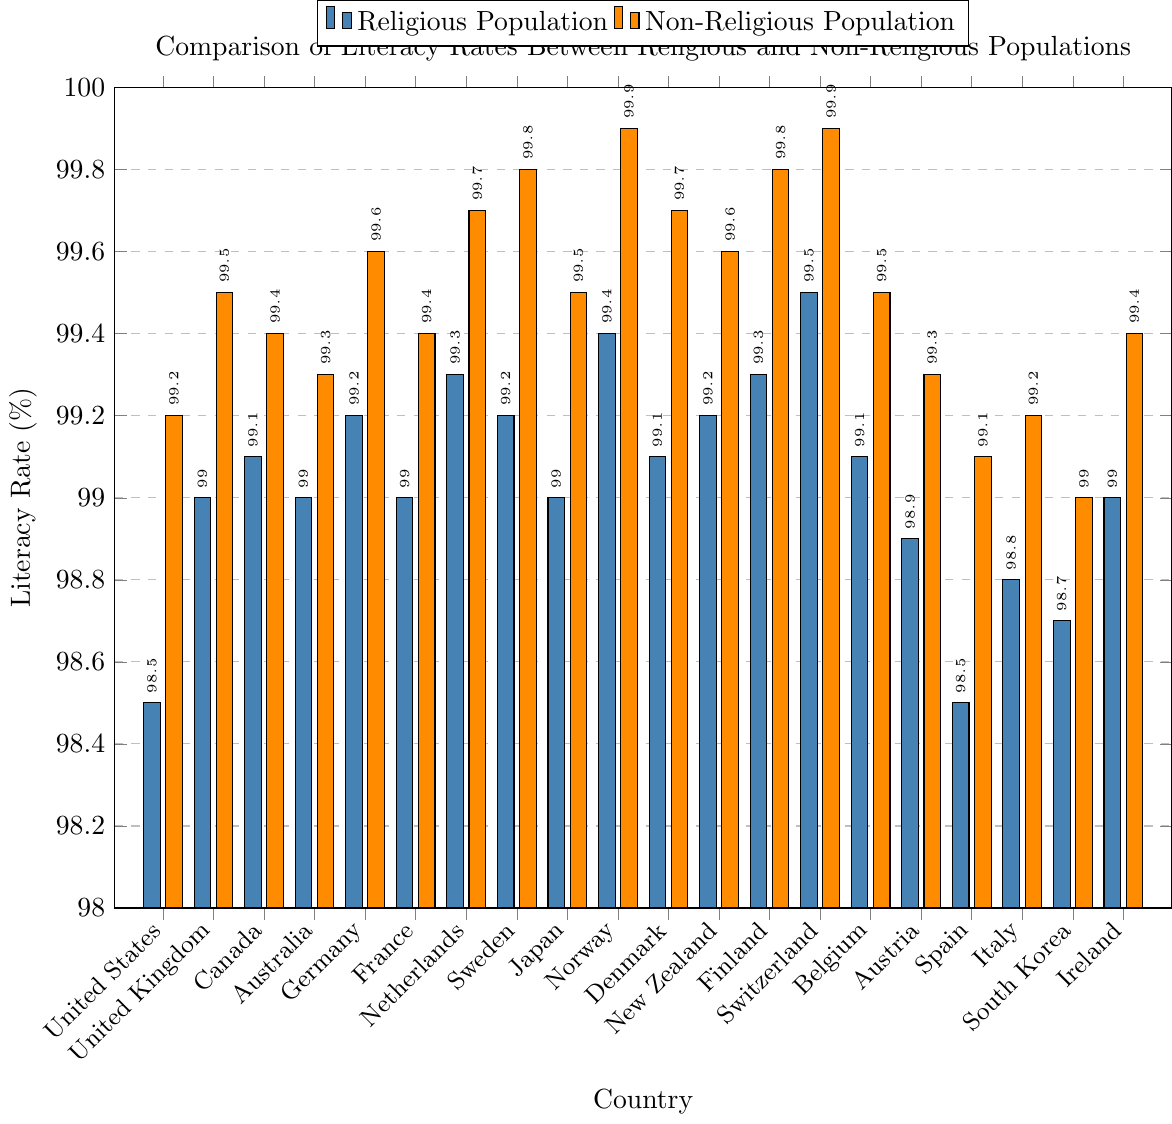Which country has the highest literacy rate among the non-religious population? Look for the tallest orange bar in the chart as it represents the non-religious population literacy rate, the tallest is Norway and Switzerland with literacy rates of 99.9%.
Answer: Norway and Switzerland What is the literacy rate difference between religious and non-religious populations in the United States? Identify the literacy rates for both populations in the United States, i.e., 98.5% (religious) and 99.2% (non-religious), then calculate the difference: 99.2% - 98.5% = 0.7%.
Answer: 0.7% Which country has the smallest difference in literacy rates between its religious and non-religious populations? For each country, compute the difference between religious and non-religious literacy rates. Denmark has a difference of only 0.6%, from 99.1% (religious) to 99.7% (non-religious).
Answer: Denmark In how many countries is the literacy rate of the non-religious population higher than that of the religious population by at least 0.5%? Calculate the literacy rate difference for each country, count the number of countries where the difference is 0.5% or more: United States (0.7%), United Kingdom (0.5%), Germany (0.4%), Netherlands (0.4%), Sweden (0.6%), Norway (0.5%), Denmark (0.6%), Finland (0.5%), Switzerland (0.4%). There are 8 such countries.
Answer: 8 What is the average literacy rate of the religious population in the listed countries? Sum the literacy rates of the religious populations (98.5 + 99.0 + 99.1 + 99.0 + 99.2 + 99.0 + 99.3 + 99.2 + 99.0 + 99.4 + 99.1 + 99.2 + 99.3 + 99.5 + 99.1 + 98.9 + 98.5 + 98.8 + 98.7 + 99.0) = 1976.9, then divide by the number of countries (20): 1976.9 / 20 = 98.845.
Answer: 98.845 Is the literacy rate higher in the religious or non-religious population in Italy? Check the bar heights for Italy, the religious population is at 98.8% and the non-religious is at 99.2%, so the non-religious literacy rate is higher.
Answer: Non-religious Which country shows the largest literacy rate for the religious population? Find the tallest blue bar, which represents the literacy rate for the religious population. Switzerland with 99.5% has the highest literacy rate.
Answer: Switzerland How many countries have a religious literacy rate below 99%? Count the number of blue bars representing the religious literacy rates below 99%: United States, Austria, Spain, Italy, and South Korea. There are 5 such countries.
Answer: 5 What is the literacy rate in the non-religious population in Finland? Look at the height of the orange bar for Finland, which stands at 99.8%.
Answer: 99.8% Which country has a larger literacy rate difference between religious and non-religious populations: Germany or France? Calculate the difference for Germany (99.6% - 99.2% = 0.4%) and compare with France (99.4% - 99.0% = 0.4%). Germany and France both have an equal difference.
Answer: Both have equal difference 